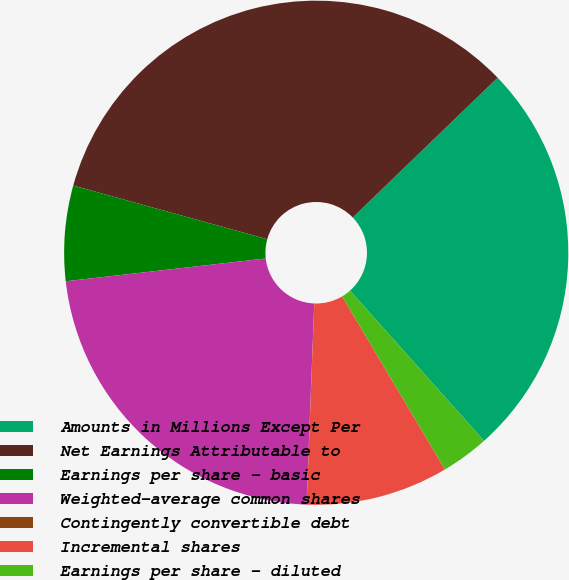<chart> <loc_0><loc_0><loc_500><loc_500><pie_chart><fcel>Amounts in Millions Except Per<fcel>Net Earnings Attributable to<fcel>Earnings per share - basic<fcel>Weighted-average common shares<fcel>Contingently convertible debt<fcel>Incremental shares<fcel>Earnings per share - diluted<nl><fcel>25.62%<fcel>33.49%<fcel>6.1%<fcel>22.58%<fcel>0.01%<fcel>9.14%<fcel>3.06%<nl></chart> 